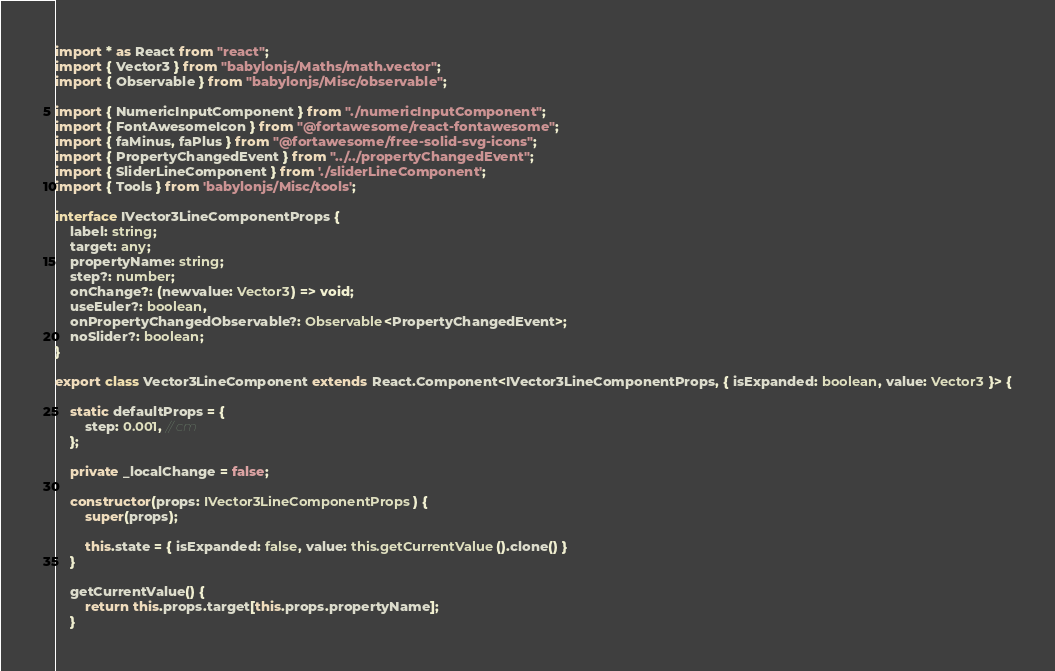Convert code to text. <code><loc_0><loc_0><loc_500><loc_500><_TypeScript_>import * as React from "react";
import { Vector3 } from "babylonjs/Maths/math.vector";
import { Observable } from "babylonjs/Misc/observable";

import { NumericInputComponent } from "./numericInputComponent";
import { FontAwesomeIcon } from "@fortawesome/react-fontawesome";
import { faMinus, faPlus } from "@fortawesome/free-solid-svg-icons";
import { PropertyChangedEvent } from "../../propertyChangedEvent";
import { SliderLineComponent } from './sliderLineComponent';
import { Tools } from 'babylonjs/Misc/tools';

interface IVector3LineComponentProps {
    label: string;
    target: any;
    propertyName: string;
    step?: number;
    onChange?: (newvalue: Vector3) => void;
    useEuler?: boolean,
    onPropertyChangedObservable?: Observable<PropertyChangedEvent>;
    noSlider?: boolean;
}

export class Vector3LineComponent extends React.Component<IVector3LineComponentProps, { isExpanded: boolean, value: Vector3 }> {

    static defaultProps = {
        step: 0.001, // cm
    };

    private _localChange = false;

    constructor(props: IVector3LineComponentProps) {
        super(props);

        this.state = { isExpanded: false, value: this.getCurrentValue().clone() }
    }

    getCurrentValue() {
        return this.props.target[this.props.propertyName];
    }
</code> 